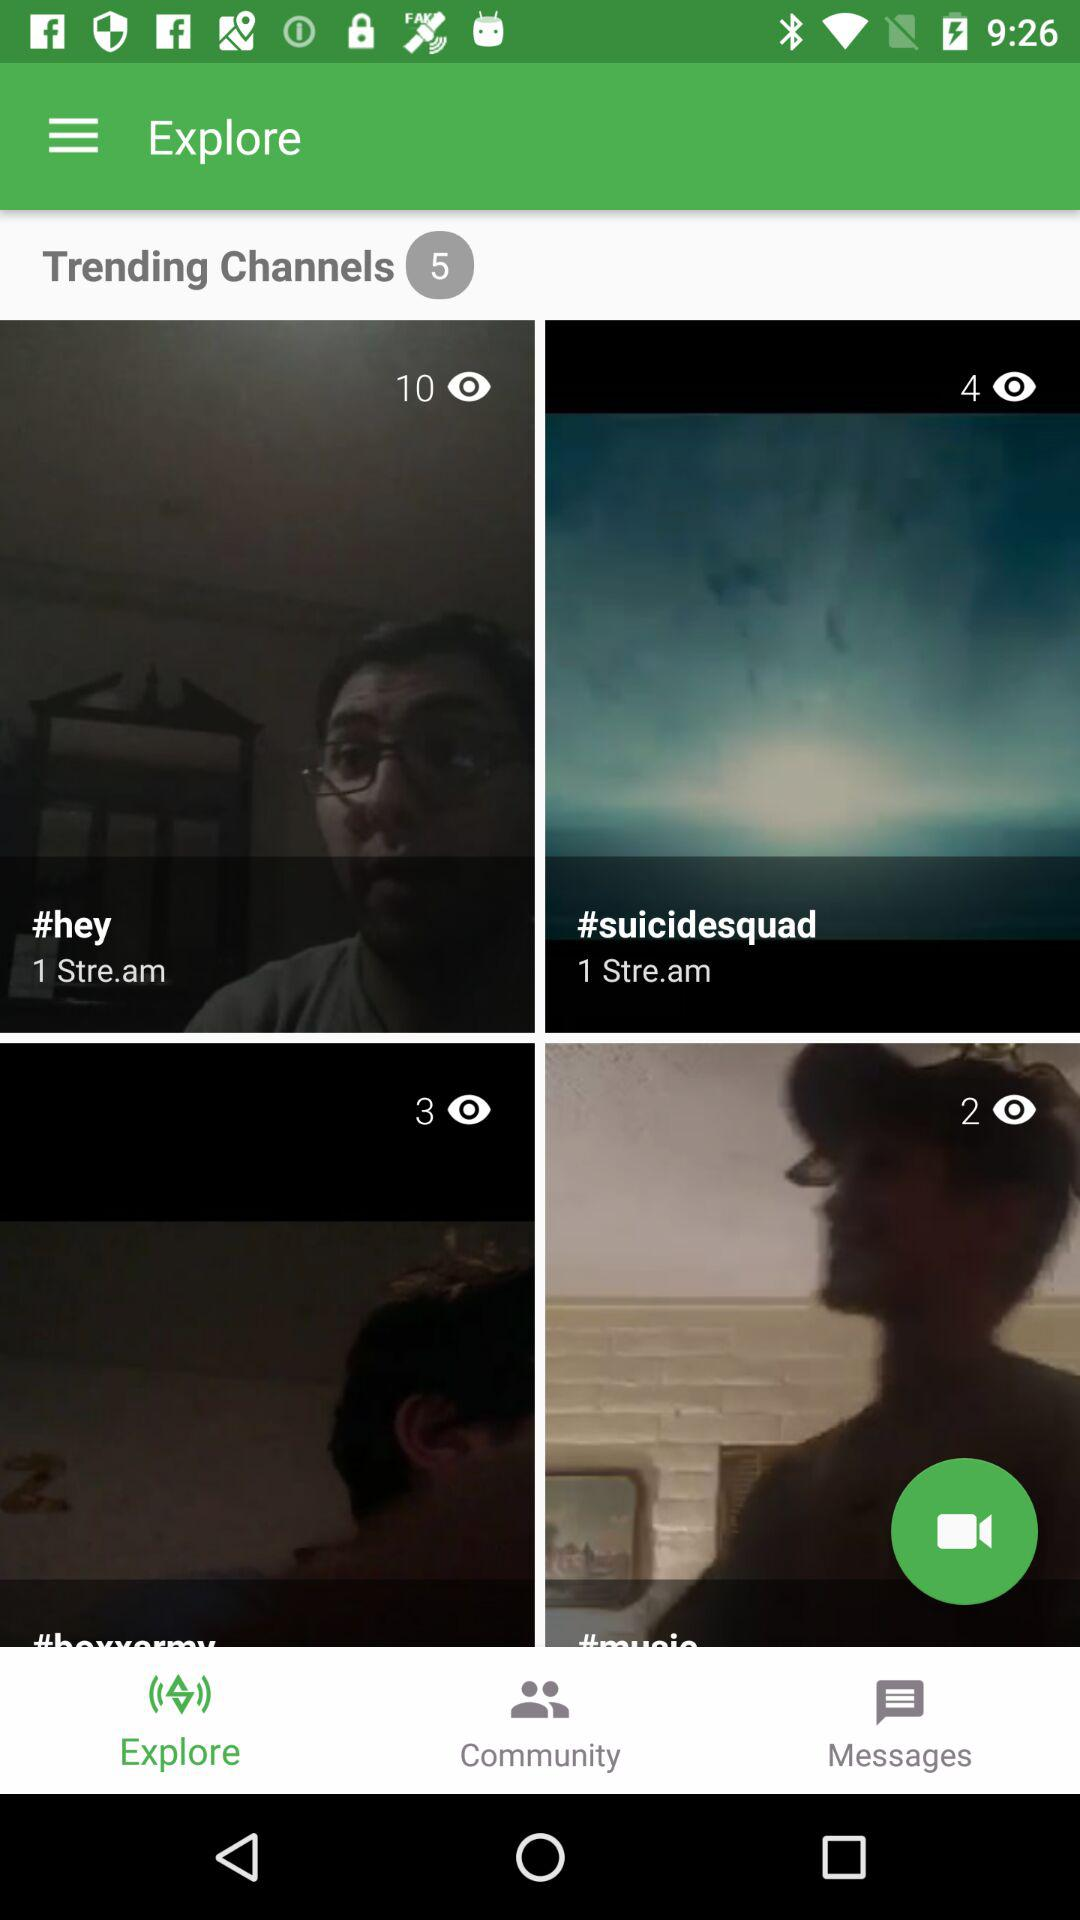Which tab is selected? The selected tab is "Explore". 